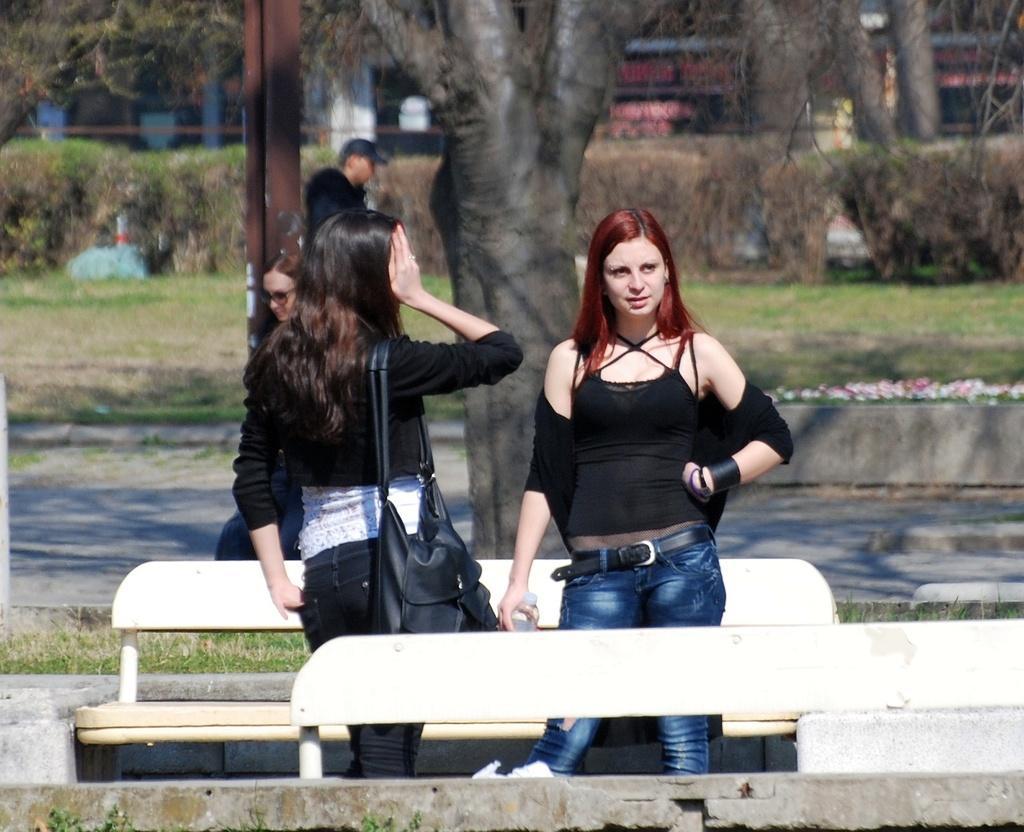Describe this image in one or two sentences. Two women are standing. Woman on the left is wearing a handbag. There are two benches. In the back there is a road, trees. Some persons are walking. There is a pillar. Some buildings are over there. Also there are some bushes and a grass lawn. 